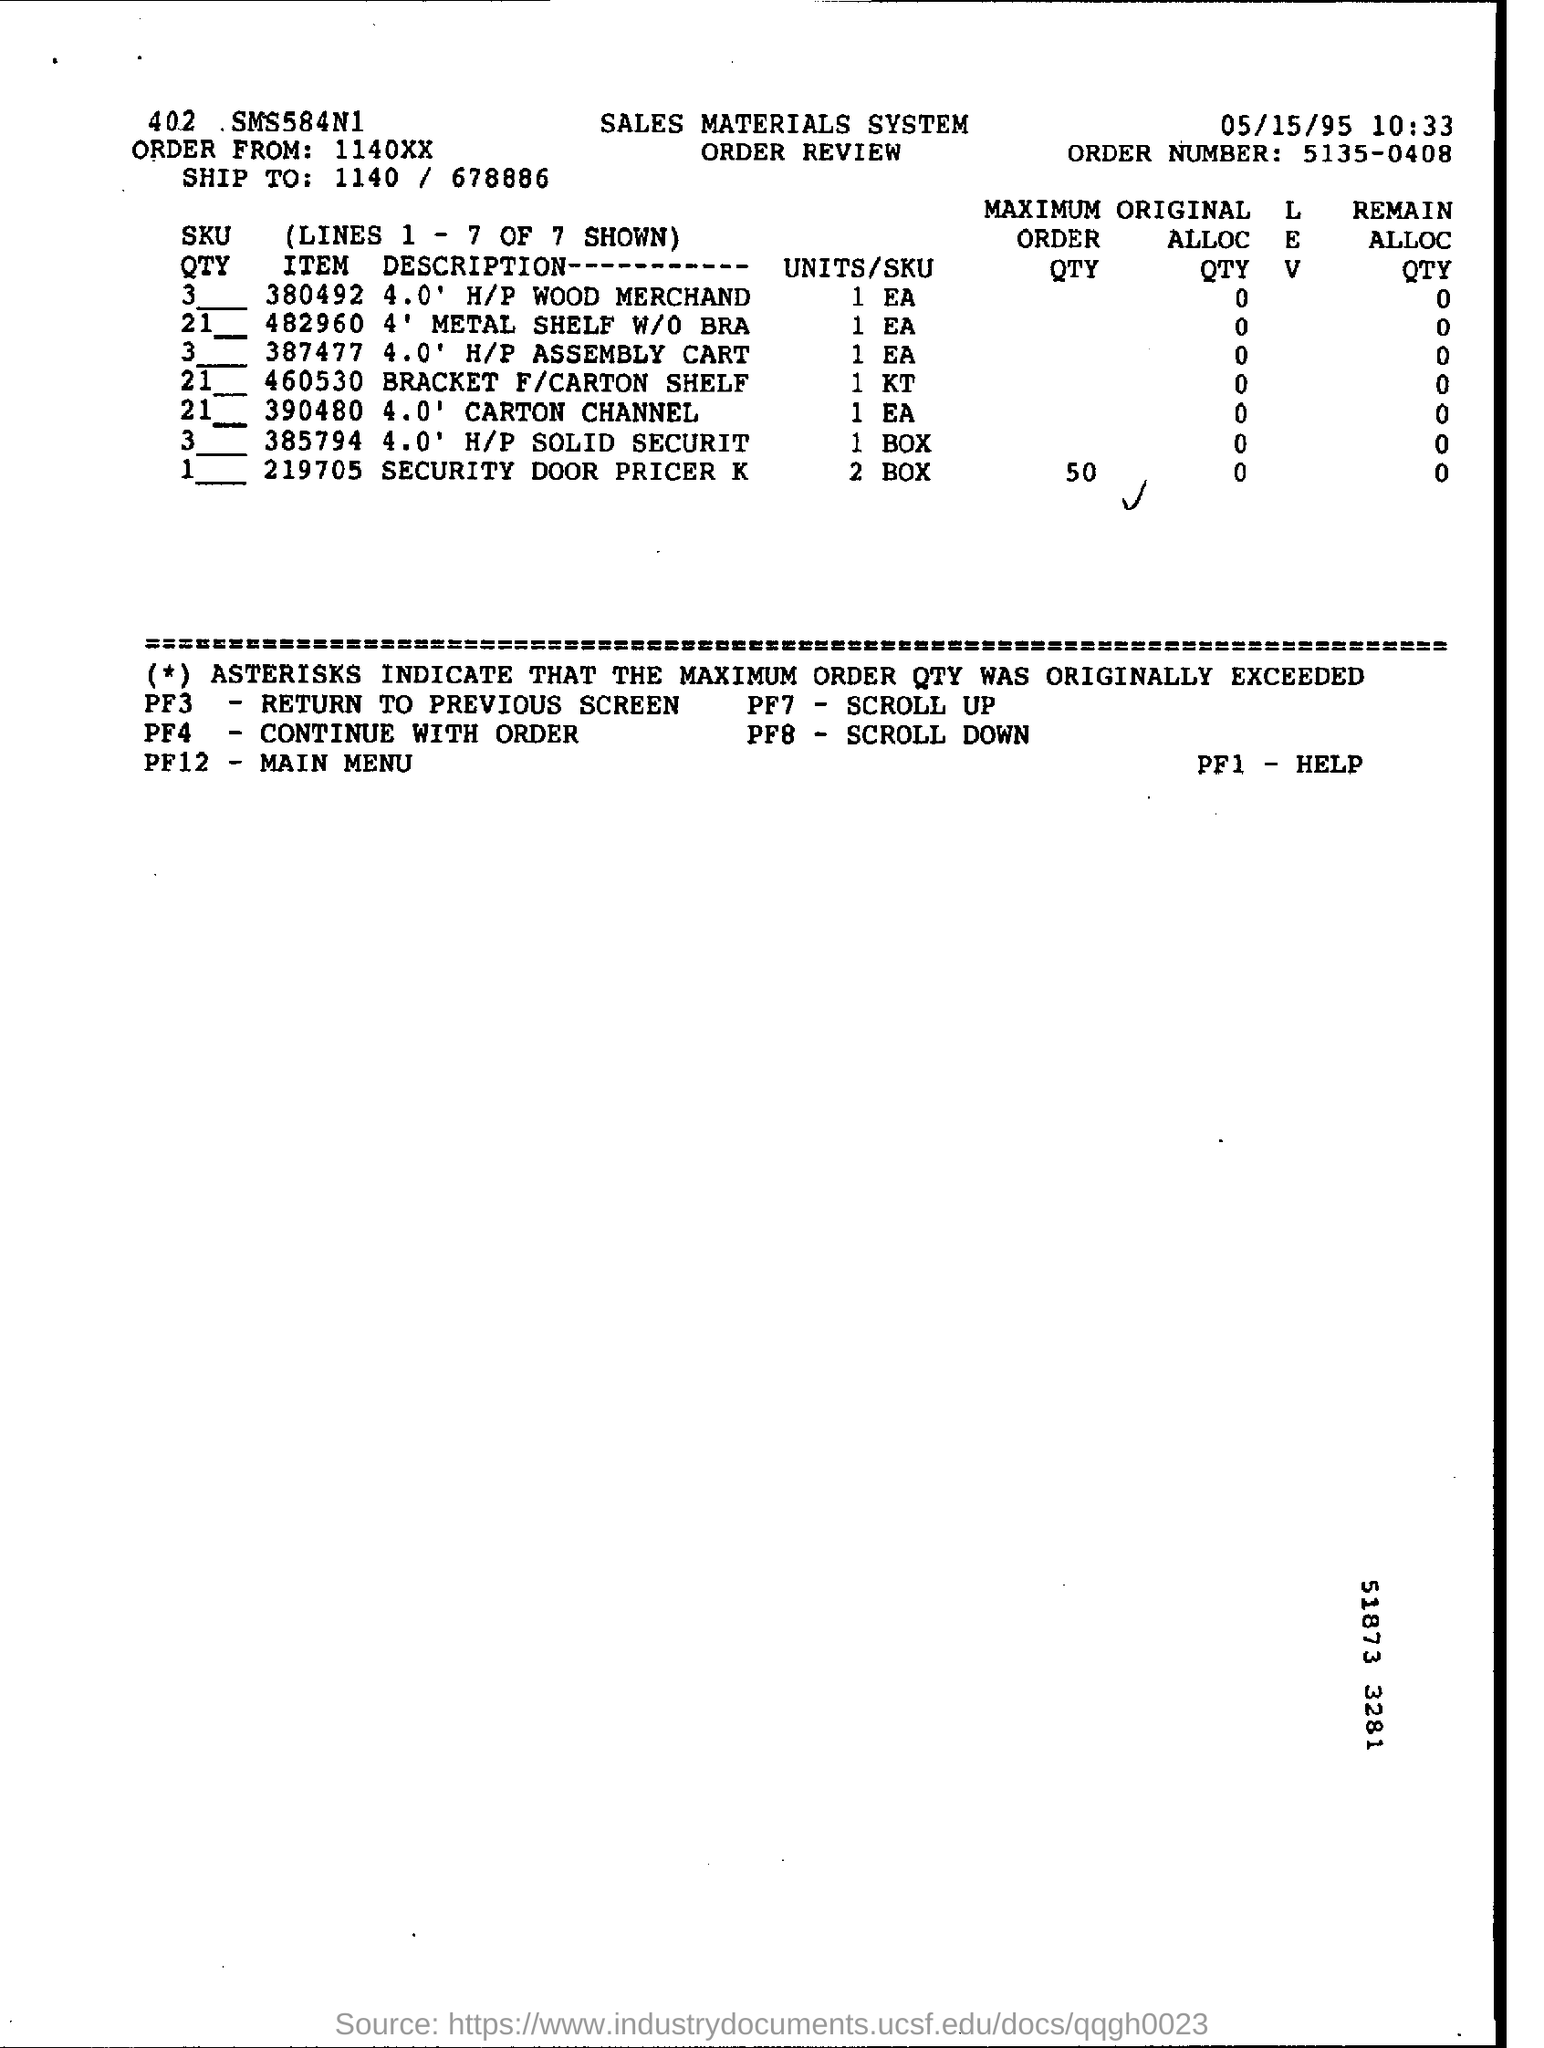Indicate a few pertinent items in this graphic. The date mentioned in the given page is May 15th, 1995. What is the time displayed on the given form? The order number mentioned is 5135-0408. The order is from the numbers mentioned as 1140XX..., 